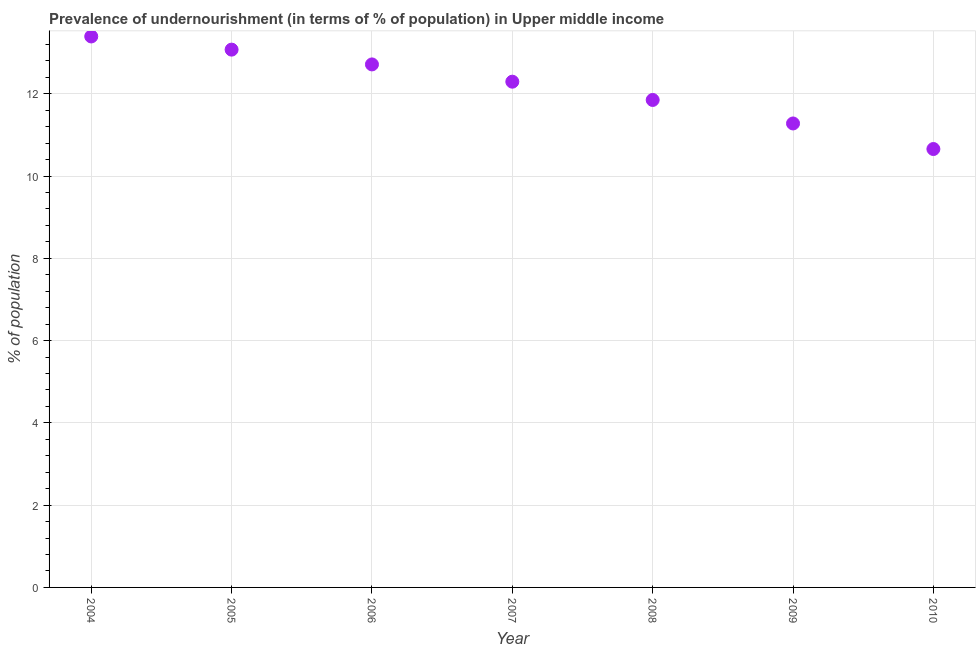What is the percentage of undernourished population in 2009?
Offer a terse response. 11.28. Across all years, what is the maximum percentage of undernourished population?
Ensure brevity in your answer.  13.39. Across all years, what is the minimum percentage of undernourished population?
Make the answer very short. 10.66. What is the sum of the percentage of undernourished population?
Ensure brevity in your answer.  85.26. What is the difference between the percentage of undernourished population in 2004 and 2006?
Provide a succinct answer. 0.68. What is the average percentage of undernourished population per year?
Give a very brief answer. 12.18. What is the median percentage of undernourished population?
Provide a succinct answer. 12.29. Do a majority of the years between 2004 and 2005 (inclusive) have percentage of undernourished population greater than 2 %?
Your answer should be very brief. Yes. What is the ratio of the percentage of undernourished population in 2005 to that in 2009?
Ensure brevity in your answer.  1.16. Is the percentage of undernourished population in 2006 less than that in 2008?
Keep it short and to the point. No. What is the difference between the highest and the second highest percentage of undernourished population?
Provide a succinct answer. 0.32. Is the sum of the percentage of undernourished population in 2006 and 2010 greater than the maximum percentage of undernourished population across all years?
Your answer should be very brief. Yes. What is the difference between the highest and the lowest percentage of undernourished population?
Your response must be concise. 2.74. In how many years, is the percentage of undernourished population greater than the average percentage of undernourished population taken over all years?
Offer a very short reply. 4. How many dotlines are there?
Keep it short and to the point. 1. Does the graph contain any zero values?
Ensure brevity in your answer.  No. What is the title of the graph?
Ensure brevity in your answer.  Prevalence of undernourishment (in terms of % of population) in Upper middle income. What is the label or title of the Y-axis?
Provide a short and direct response. % of population. What is the % of population in 2004?
Make the answer very short. 13.39. What is the % of population in 2005?
Your response must be concise. 13.07. What is the % of population in 2006?
Offer a very short reply. 12.71. What is the % of population in 2007?
Provide a short and direct response. 12.29. What is the % of population in 2008?
Offer a very short reply. 11.85. What is the % of population in 2009?
Your answer should be very brief. 11.28. What is the % of population in 2010?
Provide a short and direct response. 10.66. What is the difference between the % of population in 2004 and 2005?
Your answer should be very brief. 0.32. What is the difference between the % of population in 2004 and 2006?
Keep it short and to the point. 0.68. What is the difference between the % of population in 2004 and 2007?
Your answer should be compact. 1.1. What is the difference between the % of population in 2004 and 2008?
Provide a short and direct response. 1.54. What is the difference between the % of population in 2004 and 2009?
Your response must be concise. 2.12. What is the difference between the % of population in 2004 and 2010?
Keep it short and to the point. 2.74. What is the difference between the % of population in 2005 and 2006?
Your answer should be very brief. 0.36. What is the difference between the % of population in 2005 and 2007?
Your answer should be very brief. 0.78. What is the difference between the % of population in 2005 and 2008?
Offer a very short reply. 1.22. What is the difference between the % of population in 2005 and 2009?
Make the answer very short. 1.8. What is the difference between the % of population in 2005 and 2010?
Ensure brevity in your answer.  2.42. What is the difference between the % of population in 2006 and 2007?
Give a very brief answer. 0.42. What is the difference between the % of population in 2006 and 2008?
Provide a succinct answer. 0.86. What is the difference between the % of population in 2006 and 2009?
Make the answer very short. 1.44. What is the difference between the % of population in 2006 and 2010?
Provide a short and direct response. 2.06. What is the difference between the % of population in 2007 and 2008?
Provide a succinct answer. 0.44. What is the difference between the % of population in 2007 and 2009?
Offer a very short reply. 1.02. What is the difference between the % of population in 2007 and 2010?
Offer a very short reply. 1.64. What is the difference between the % of population in 2008 and 2009?
Ensure brevity in your answer.  0.57. What is the difference between the % of population in 2008 and 2010?
Your answer should be very brief. 1.19. What is the difference between the % of population in 2009 and 2010?
Offer a terse response. 0.62. What is the ratio of the % of population in 2004 to that in 2005?
Give a very brief answer. 1.02. What is the ratio of the % of population in 2004 to that in 2006?
Make the answer very short. 1.05. What is the ratio of the % of population in 2004 to that in 2007?
Keep it short and to the point. 1.09. What is the ratio of the % of population in 2004 to that in 2008?
Your answer should be compact. 1.13. What is the ratio of the % of population in 2004 to that in 2009?
Your answer should be compact. 1.19. What is the ratio of the % of population in 2004 to that in 2010?
Ensure brevity in your answer.  1.26. What is the ratio of the % of population in 2005 to that in 2006?
Your answer should be compact. 1.03. What is the ratio of the % of population in 2005 to that in 2007?
Ensure brevity in your answer.  1.06. What is the ratio of the % of population in 2005 to that in 2008?
Offer a terse response. 1.1. What is the ratio of the % of population in 2005 to that in 2009?
Provide a short and direct response. 1.16. What is the ratio of the % of population in 2005 to that in 2010?
Keep it short and to the point. 1.23. What is the ratio of the % of population in 2006 to that in 2007?
Offer a terse response. 1.03. What is the ratio of the % of population in 2006 to that in 2008?
Provide a short and direct response. 1.07. What is the ratio of the % of population in 2006 to that in 2009?
Keep it short and to the point. 1.13. What is the ratio of the % of population in 2006 to that in 2010?
Offer a terse response. 1.19. What is the ratio of the % of population in 2007 to that in 2008?
Offer a very short reply. 1.04. What is the ratio of the % of population in 2007 to that in 2009?
Ensure brevity in your answer.  1.09. What is the ratio of the % of population in 2007 to that in 2010?
Give a very brief answer. 1.15. What is the ratio of the % of population in 2008 to that in 2009?
Keep it short and to the point. 1.05. What is the ratio of the % of population in 2008 to that in 2010?
Your response must be concise. 1.11. What is the ratio of the % of population in 2009 to that in 2010?
Your answer should be very brief. 1.06. 